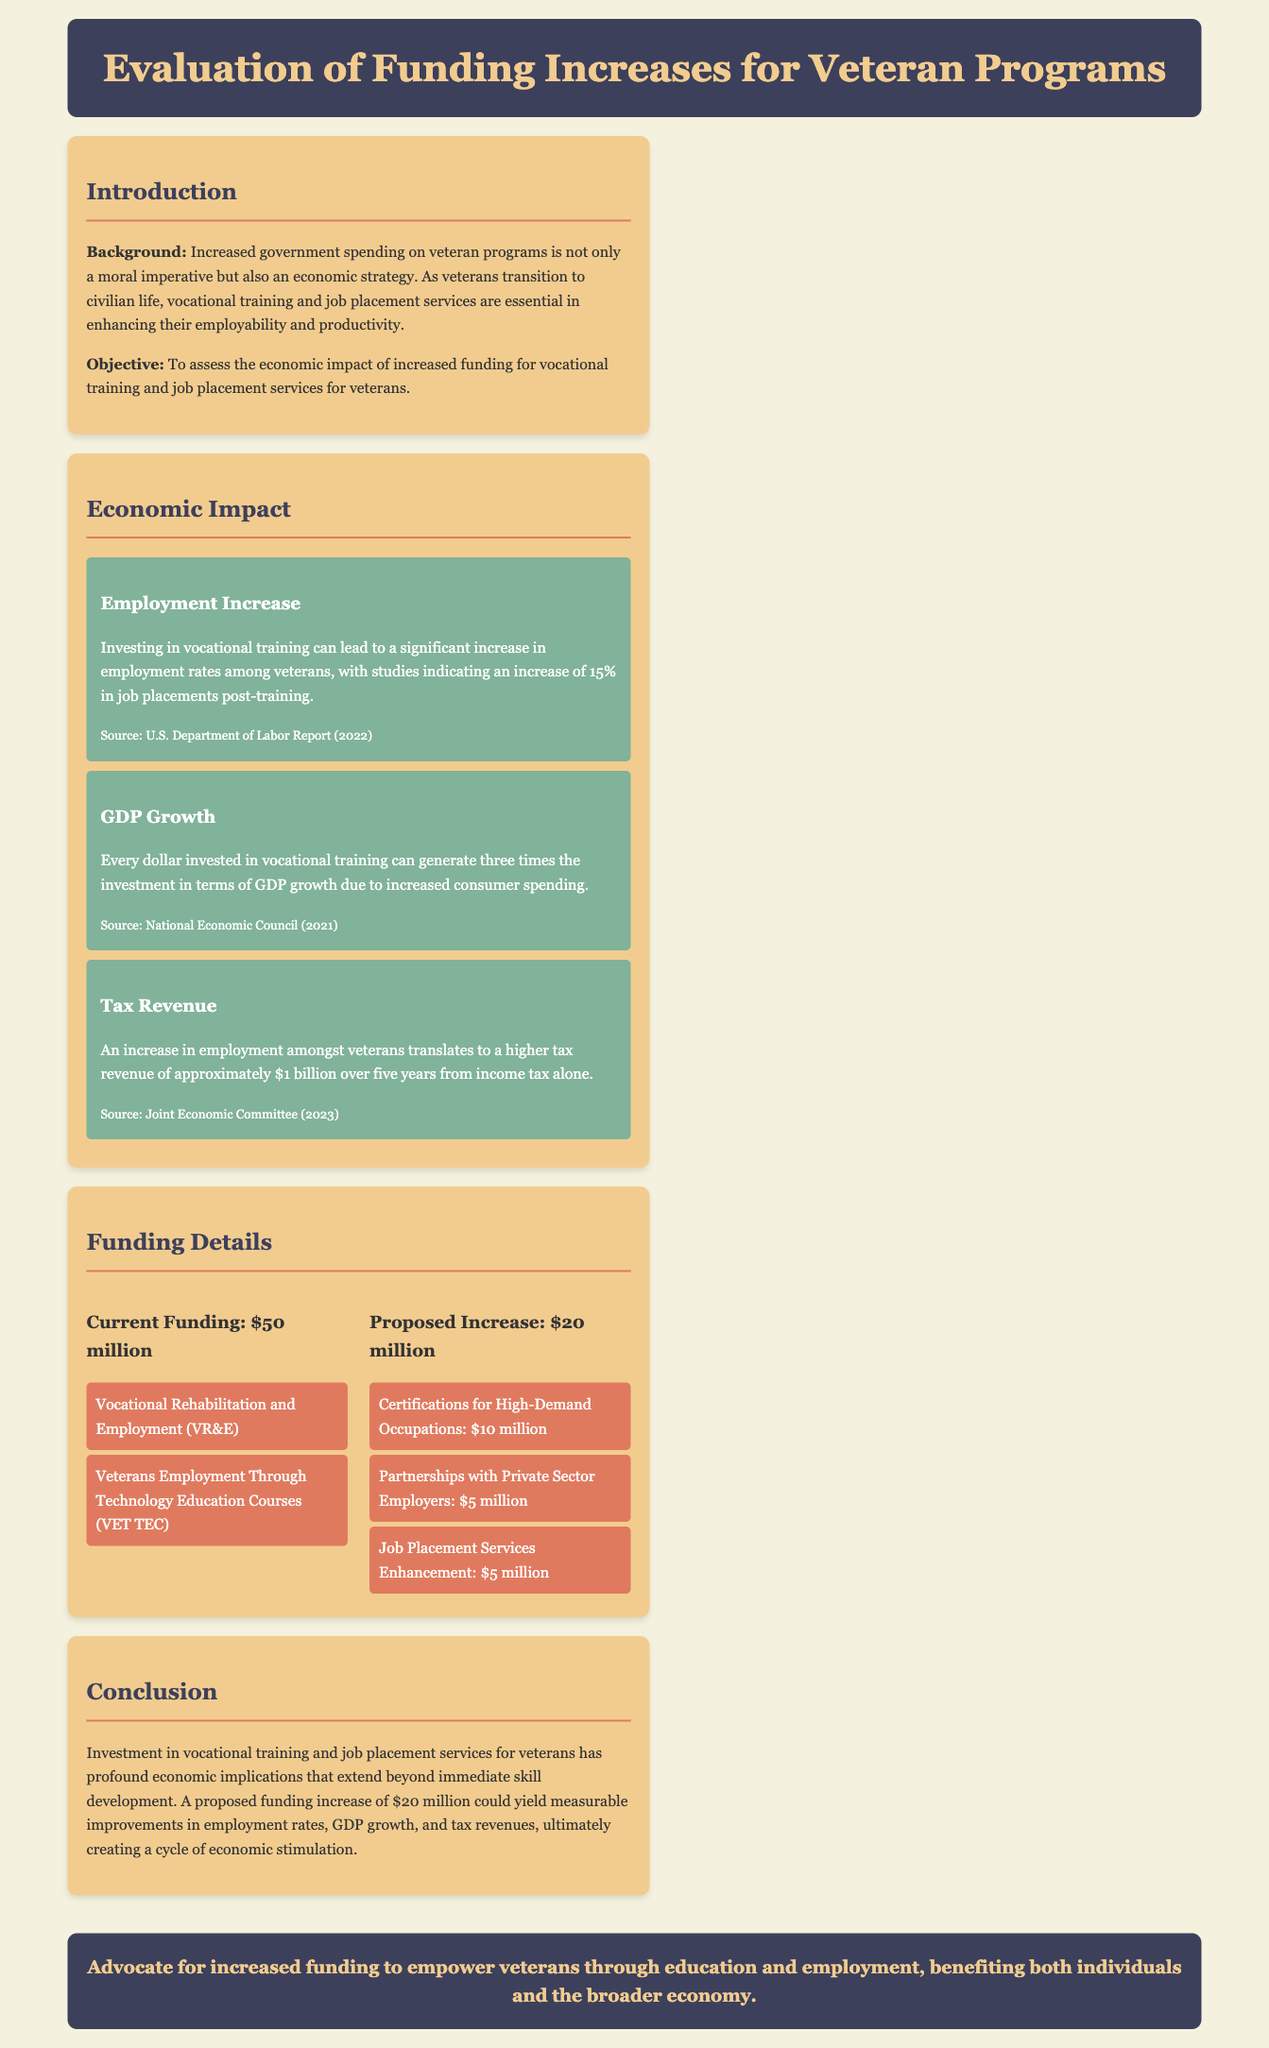What is the current funding for veteran programs? The document states that the current funding is $50 million.
Answer: $50 million What is the proposed increase for vocational training services? The proposed increase is stated as $20 million.
Answer: $20 million What percentage increase in job placements is expected post-training? The document indicates a 15% increase in job placements post-training.
Answer: 15% How much tax revenue is projected to be generated over five years? The projected tax revenue is approximately $1 billion over five years.
Answer: $1 billion What is the return on investment for every dollar in vocational training? The document states that every dollar invested generates three times the investment in GDP growth.
Answer: Three times What programs are included under the current funding? The current funding includes Vocational Rehabilitation and Employment (VR&E) and Veterans Employment Through Technology Education Courses (VET TEC).
Answer: VR&E, VET TEC What is the amount allocated for Certifications for High-Demand Occupations in the proposed budget? The amount allocated for Certifications for High-Demand Occupations is $10 million.
Answer: $10 million What is the main objective of the funding evaluation? The main objective is to assess the economic impact of increased funding for vocational training and job placement services for veterans.
Answer: Assess economic impact What is the background rationale for increased government spending on veterans? Increased government spending is presented as a moral imperative and an economic strategy.
Answer: Moral imperative and economic strategy 